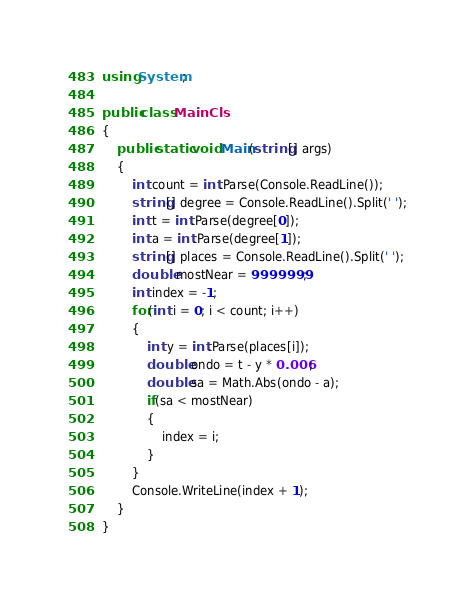<code> <loc_0><loc_0><loc_500><loc_500><_C#_>using System;

public class MainCls
{
	public static void Main(string[] args)
	{
		int count = int.Parse(Console.ReadLine());
		string[] degree = Console.ReadLine().Split(' ');
		int t = int.Parse(degree[0]);
		int a = int.Parse(degree[1]);
		string[] places = Console.ReadLine().Split(' ');
		double mostNear = 9999999;
		int index = -1;
		for(int i = 0; i < count; i++)
		{
			int y = int.Parse(places[i]);
			double ondo = t - y * 0.006;
			double sa = Math.Abs(ondo - a);
			if(sa < mostNear)
			{
				index = i;
			}
		}
		Console.WriteLine(index + 1);
	}
}</code> 